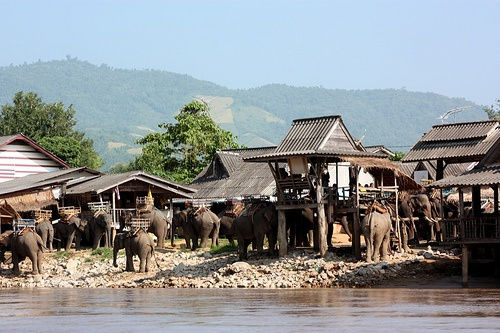Describe the objects in this image and their specific colors. I can see elephant in lightblue, black, and gray tones, elephant in lightblue, black, tan, gray, and maroon tones, elephant in lightblue, black, gray, tan, and maroon tones, elephant in lightblue, black, tan, and gray tones, and elephant in lightblue, tan, black, and gray tones in this image. 